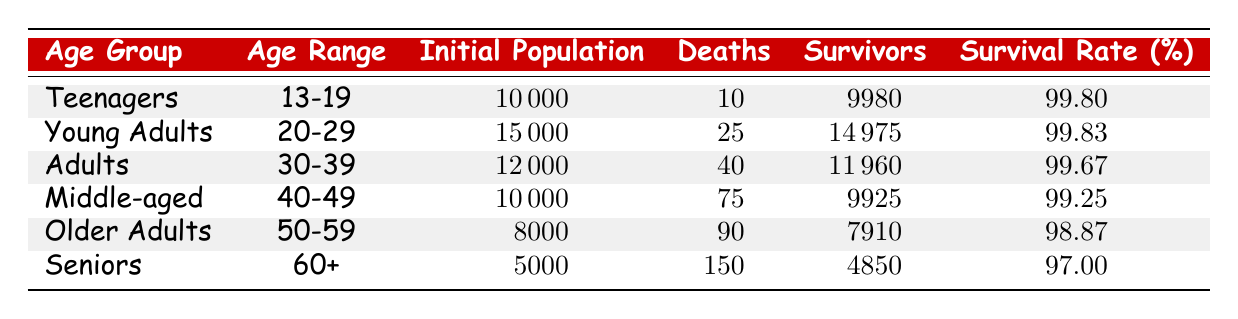What is the survival rate for the "Older Adults" age group? The survival rate is stated directly in the table under the "Survival Rate (%)" column for the "Older Adults" age group. It shows a survival rate of 98.87%.
Answer: 98.87 How many total deaths occurred across all age groups? To find the total deaths, we sum the "Deaths" column: 10 (Teenagers) + 25 (Young Adults) + 40 (Adults) + 75 (Middle-aged) + 90 (Older Adults) + 150 (Seniors) = 390.
Answer: 390 Did more than 50 deaths occur in the "Adults" group? The "Deaths" column shows that 40 deaths occurred in the "Adults" group, which is less than 50. Thus, the statement is false.
Answer: No What is the initial population of the "Young Adults" age group? The initial population for the "Young Adults" age group is given in the table as 15,000.
Answer: 15000 Which age group has the highest survival rate? We can compare the "Survival Rate (%)" for each age group. The "Young Adults" group has the highest survival rate of 99.83%.
Answer: Young Adults What is the total population of the "Middle-aged" and "Seniors" groups combined? We add the "Initial Population" of both groups: 10,000 (Middle-aged) + 5,000 (Seniors) = 15,000.
Answer: 15000 Is the survival rate for "Teenagers" higher than that for "Seniors"? The table lists the survival rate for "Teenagers" as 99.80% and for "Seniors" as 97.00%. Since 99.80% is greater than 97.00%, the statement is true.
Answer: Yes What is the average survival rate of all age groups? To calculate the average, we sum all survival rates and divide by the number of groups: (99.80 + 99.83 + 99.67 + 99.25 + 98.87 + 97.00) / 6 = 99.18.
Answer: 99.18 How many survivors are there in the "Older Adults" group? The "Survivors" column indicates that there are 7,910 survivors in the "Older Adults" group.
Answer: 7910 